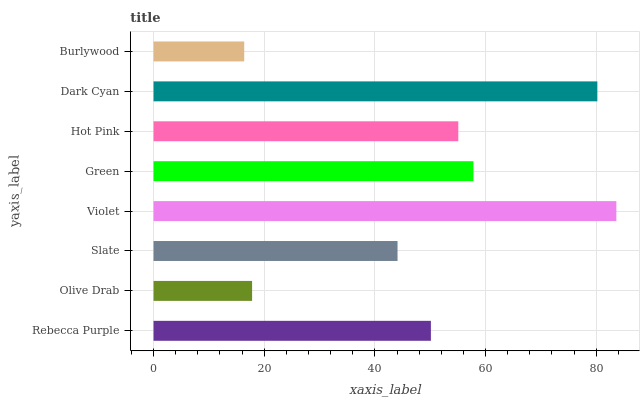Is Burlywood the minimum?
Answer yes or no. Yes. Is Violet the maximum?
Answer yes or no. Yes. Is Olive Drab the minimum?
Answer yes or no. No. Is Olive Drab the maximum?
Answer yes or no. No. Is Rebecca Purple greater than Olive Drab?
Answer yes or no. Yes. Is Olive Drab less than Rebecca Purple?
Answer yes or no. Yes. Is Olive Drab greater than Rebecca Purple?
Answer yes or no. No. Is Rebecca Purple less than Olive Drab?
Answer yes or no. No. Is Hot Pink the high median?
Answer yes or no. Yes. Is Rebecca Purple the low median?
Answer yes or no. Yes. Is Dark Cyan the high median?
Answer yes or no. No. Is Violet the low median?
Answer yes or no. No. 